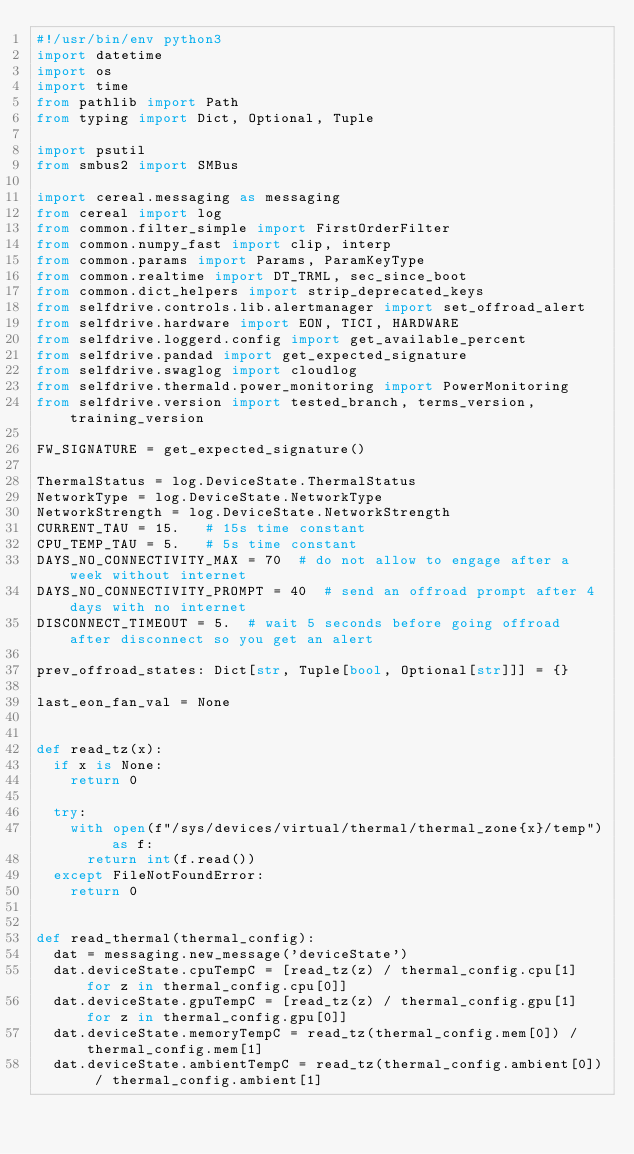<code> <loc_0><loc_0><loc_500><loc_500><_Python_>#!/usr/bin/env python3
import datetime
import os
import time
from pathlib import Path
from typing import Dict, Optional, Tuple

import psutil
from smbus2 import SMBus

import cereal.messaging as messaging
from cereal import log
from common.filter_simple import FirstOrderFilter
from common.numpy_fast import clip, interp
from common.params import Params, ParamKeyType
from common.realtime import DT_TRML, sec_since_boot
from common.dict_helpers import strip_deprecated_keys
from selfdrive.controls.lib.alertmanager import set_offroad_alert
from selfdrive.hardware import EON, TICI, HARDWARE
from selfdrive.loggerd.config import get_available_percent
from selfdrive.pandad import get_expected_signature
from selfdrive.swaglog import cloudlog
from selfdrive.thermald.power_monitoring import PowerMonitoring
from selfdrive.version import tested_branch, terms_version, training_version

FW_SIGNATURE = get_expected_signature()

ThermalStatus = log.DeviceState.ThermalStatus
NetworkType = log.DeviceState.NetworkType
NetworkStrength = log.DeviceState.NetworkStrength
CURRENT_TAU = 15.   # 15s time constant
CPU_TEMP_TAU = 5.   # 5s time constant
DAYS_NO_CONNECTIVITY_MAX = 70  # do not allow to engage after a week without internet
DAYS_NO_CONNECTIVITY_PROMPT = 40  # send an offroad prompt after 4 days with no internet
DISCONNECT_TIMEOUT = 5.  # wait 5 seconds before going offroad after disconnect so you get an alert

prev_offroad_states: Dict[str, Tuple[bool, Optional[str]]] = {}

last_eon_fan_val = None


def read_tz(x):
  if x is None:
    return 0

  try:
    with open(f"/sys/devices/virtual/thermal/thermal_zone{x}/temp") as f:
      return int(f.read())
  except FileNotFoundError:
    return 0


def read_thermal(thermal_config):
  dat = messaging.new_message('deviceState')
  dat.deviceState.cpuTempC = [read_tz(z) / thermal_config.cpu[1] for z in thermal_config.cpu[0]]
  dat.deviceState.gpuTempC = [read_tz(z) / thermal_config.gpu[1] for z in thermal_config.gpu[0]]
  dat.deviceState.memoryTempC = read_tz(thermal_config.mem[0]) / thermal_config.mem[1]
  dat.deviceState.ambientTempC = read_tz(thermal_config.ambient[0]) / thermal_config.ambient[1]</code> 